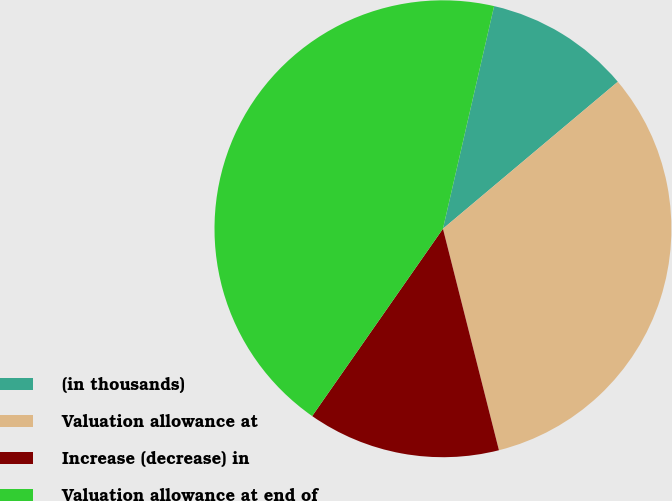Convert chart to OTSL. <chart><loc_0><loc_0><loc_500><loc_500><pie_chart><fcel>(in thousands)<fcel>Valuation allowance at<fcel>Increase (decrease) in<fcel>Valuation allowance at end of<nl><fcel>10.28%<fcel>32.18%<fcel>13.64%<fcel>43.89%<nl></chart> 